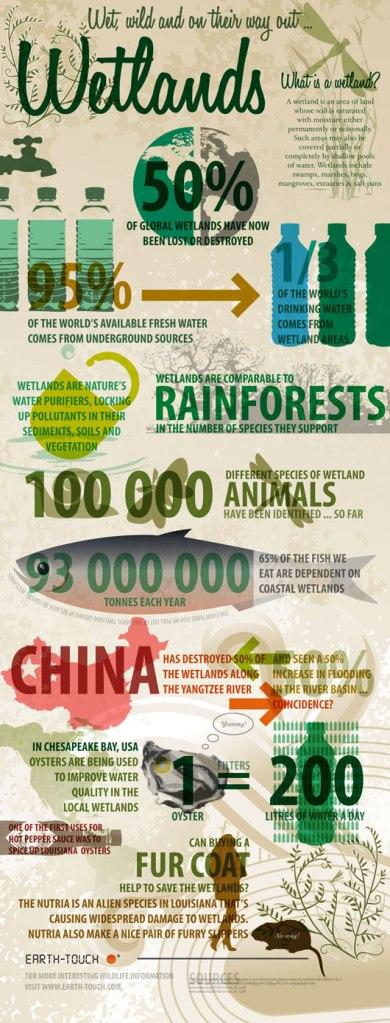Draw attention to some important aspects in this diagram. It is necessary to consume a certain number of oysters in order to improve the quality of 200 liters of water. 